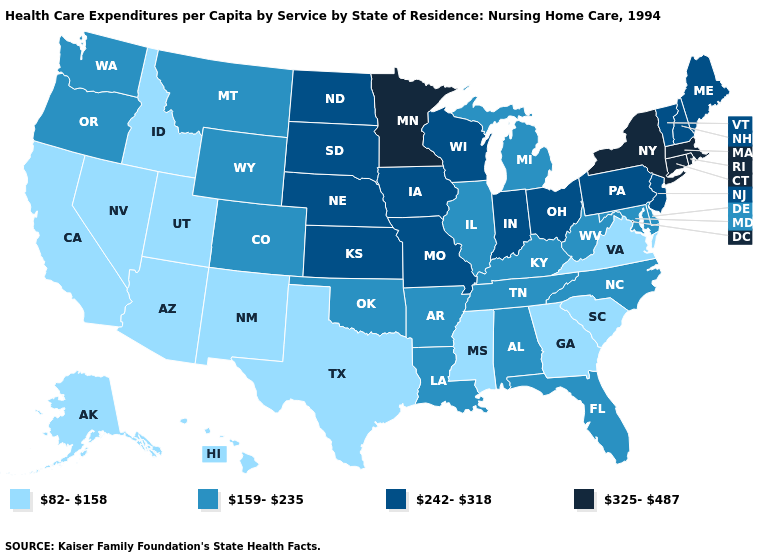Does the map have missing data?
Be succinct. No. What is the lowest value in states that border Vermont?
Give a very brief answer. 242-318. Which states have the lowest value in the USA?
Short answer required. Alaska, Arizona, California, Georgia, Hawaii, Idaho, Mississippi, Nevada, New Mexico, South Carolina, Texas, Utah, Virginia. Name the states that have a value in the range 159-235?
Give a very brief answer. Alabama, Arkansas, Colorado, Delaware, Florida, Illinois, Kentucky, Louisiana, Maryland, Michigan, Montana, North Carolina, Oklahoma, Oregon, Tennessee, Washington, West Virginia, Wyoming. Which states hav the highest value in the MidWest?
Be succinct. Minnesota. What is the value of Nebraska?
Answer briefly. 242-318. What is the value of Arkansas?
Give a very brief answer. 159-235. Name the states that have a value in the range 82-158?
Give a very brief answer. Alaska, Arizona, California, Georgia, Hawaii, Idaho, Mississippi, Nevada, New Mexico, South Carolina, Texas, Utah, Virginia. Does Michigan have the lowest value in the MidWest?
Answer briefly. Yes. What is the value of New Jersey?
Give a very brief answer. 242-318. Name the states that have a value in the range 325-487?
Concise answer only. Connecticut, Massachusetts, Minnesota, New York, Rhode Island. What is the value of Louisiana?
Quick response, please. 159-235. Does Michigan have the highest value in the MidWest?
Be succinct. No. Does Minnesota have the highest value in the MidWest?
Quick response, please. Yes. Does Nevada have the same value as Hawaii?
Concise answer only. Yes. 